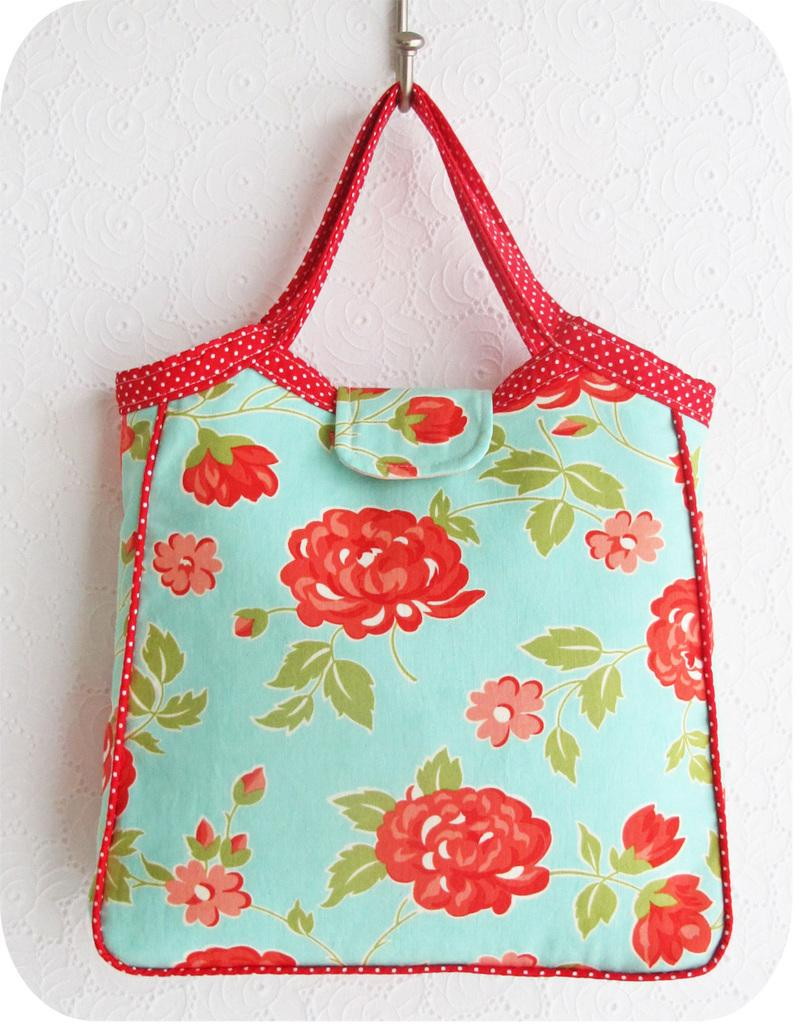What object is present in the image? There is a bag in the image. What colors can be seen on the bag? The bag has red and blue colors. How is the bag positioned in the image? The bag is hung on a hanger. What type of soap is being used to clean the bag in the image? There is no soap or cleaning activity depicted in the image; the bag is simply hung on a hanger. 